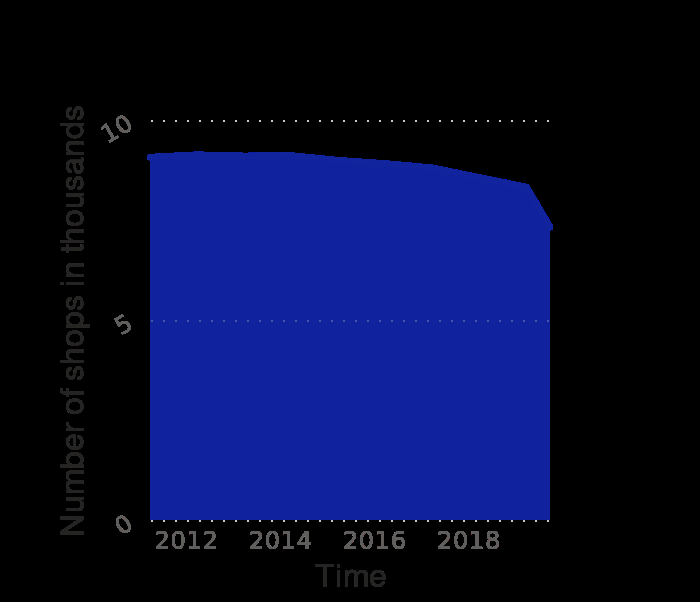<image>
What is the unit of measurement for the number of shops on the chart? The unit of measurement for the number of shops is thousands. What was the overall trend of the figures from end March 2011 until 2/3rds way through 2019? The figures showed a slow decline until 2/3rds of the way through 2019, when they dropped sharply. 